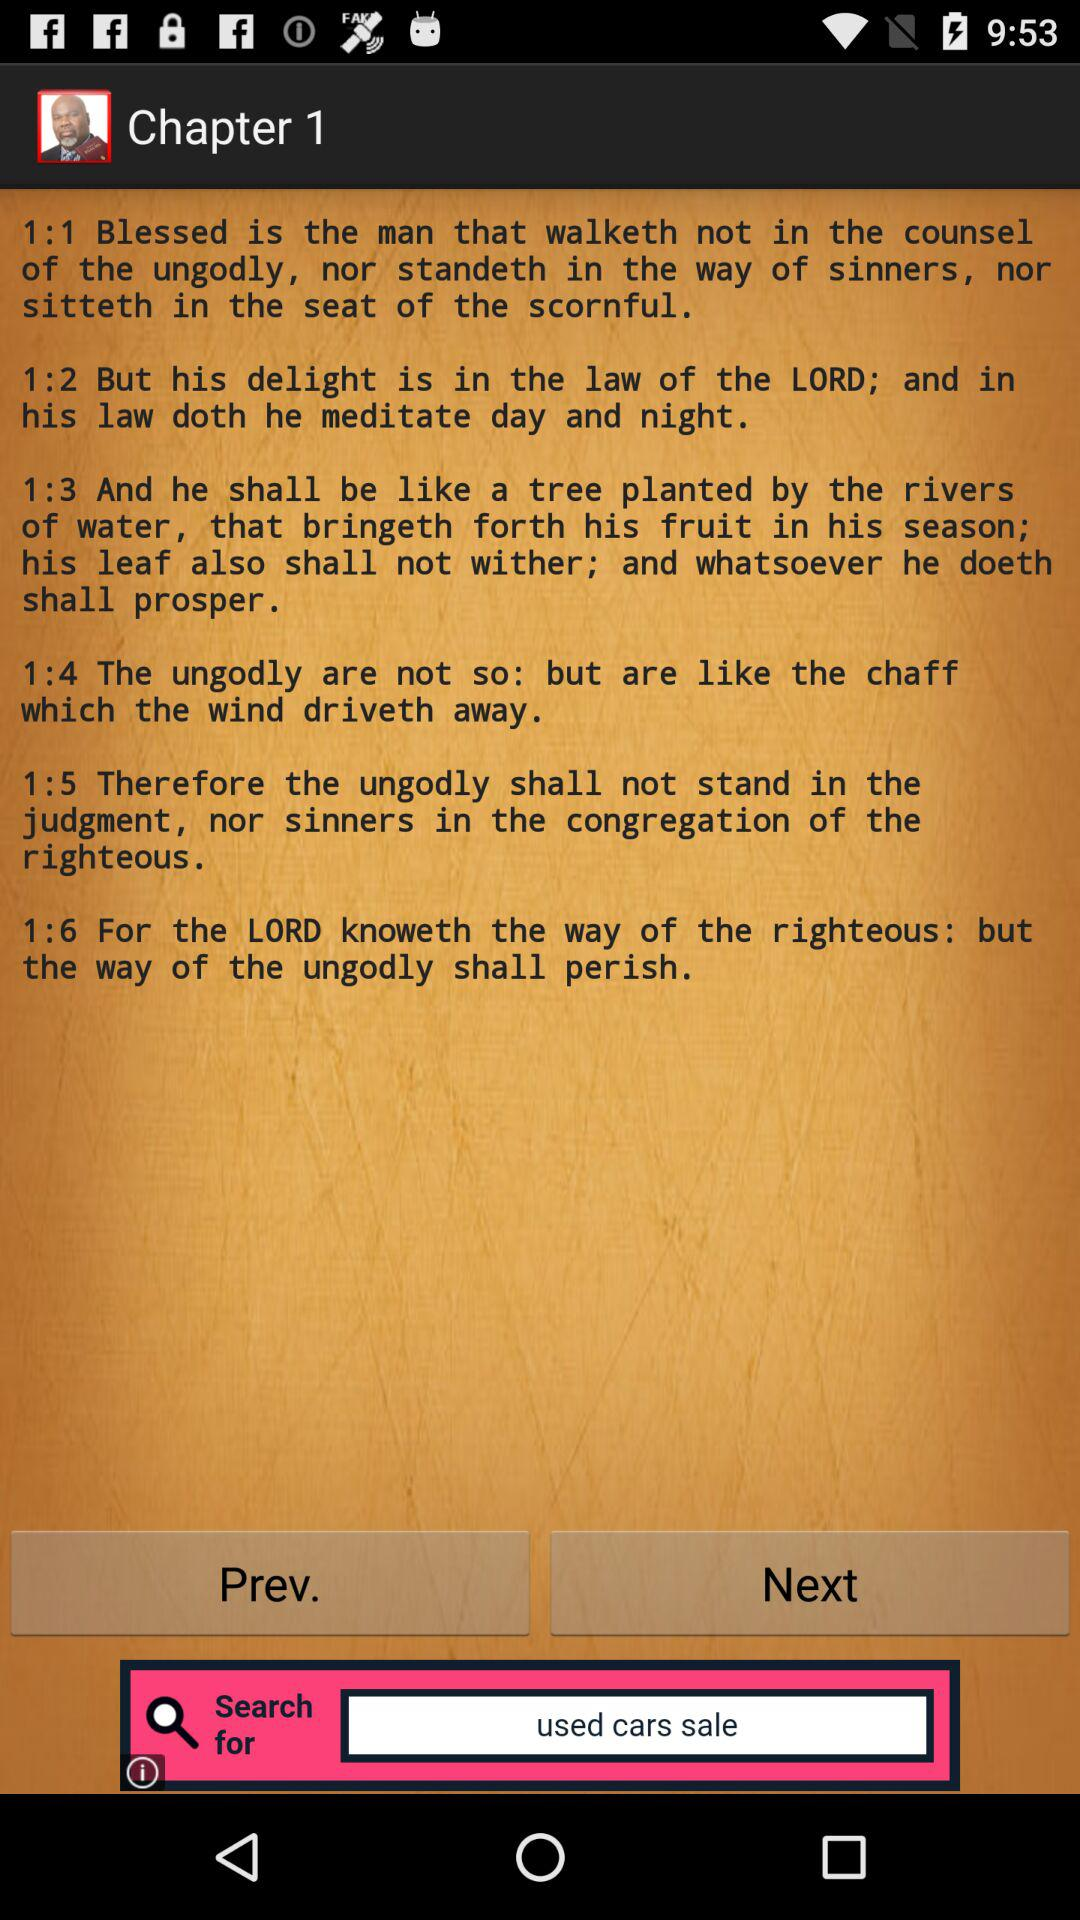How many verses are there in this chapter?
Answer the question using a single word or phrase. 6 